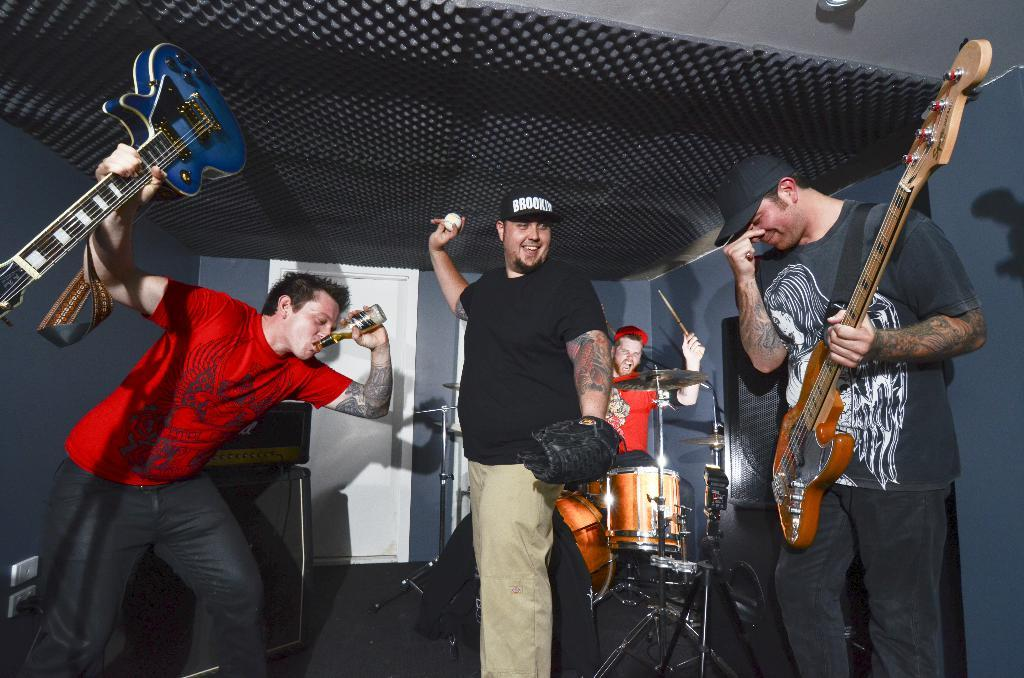How many people are in the image? There are people in the image, but the exact number is not specified. What are the people in the image doing? The people in the image are playing musical instruments. Where are the people located in the image? The people are standing in a room. What type of wound can be seen on the person playing the guitar in the image? There is no wound visible on any person in the image. Where is the nearest market to the location of the image? The provided facts do not give any information about the location of the image, so it is impossible to determine the nearest market. 